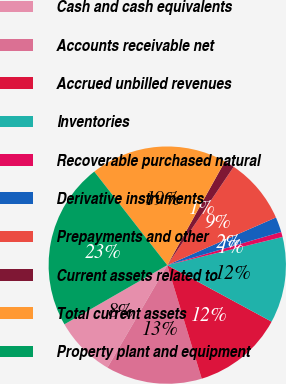Convert chart to OTSL. <chart><loc_0><loc_0><loc_500><loc_500><pie_chart><fcel>Cash and cash equivalents<fcel>Accounts receivable net<fcel>Accrued unbilled revenues<fcel>Inventories<fcel>Recoverable purchased natural<fcel>Derivative instruments<fcel>Prepayments and other<fcel>Current assets related to<fcel>Total current assets<fcel>Property plant and equipment<nl><fcel>8.28%<fcel>13.1%<fcel>12.41%<fcel>11.72%<fcel>0.69%<fcel>2.07%<fcel>8.97%<fcel>1.38%<fcel>18.62%<fcel>22.76%<nl></chart> 